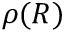<formula> <loc_0><loc_0><loc_500><loc_500>\rho ( R )</formula> 